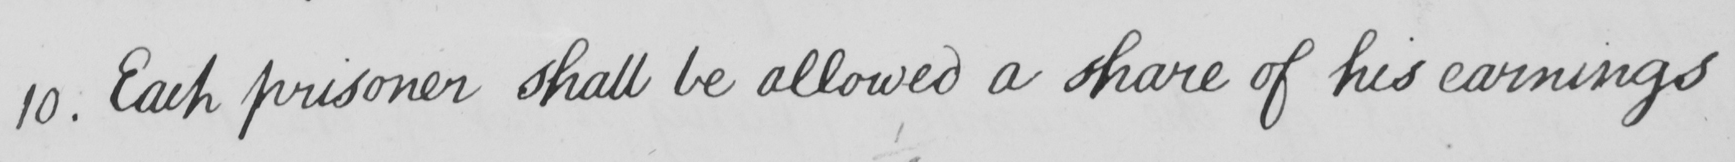What does this handwritten line say? 10 . Each prisoner shall be allowed a share of his earnings 